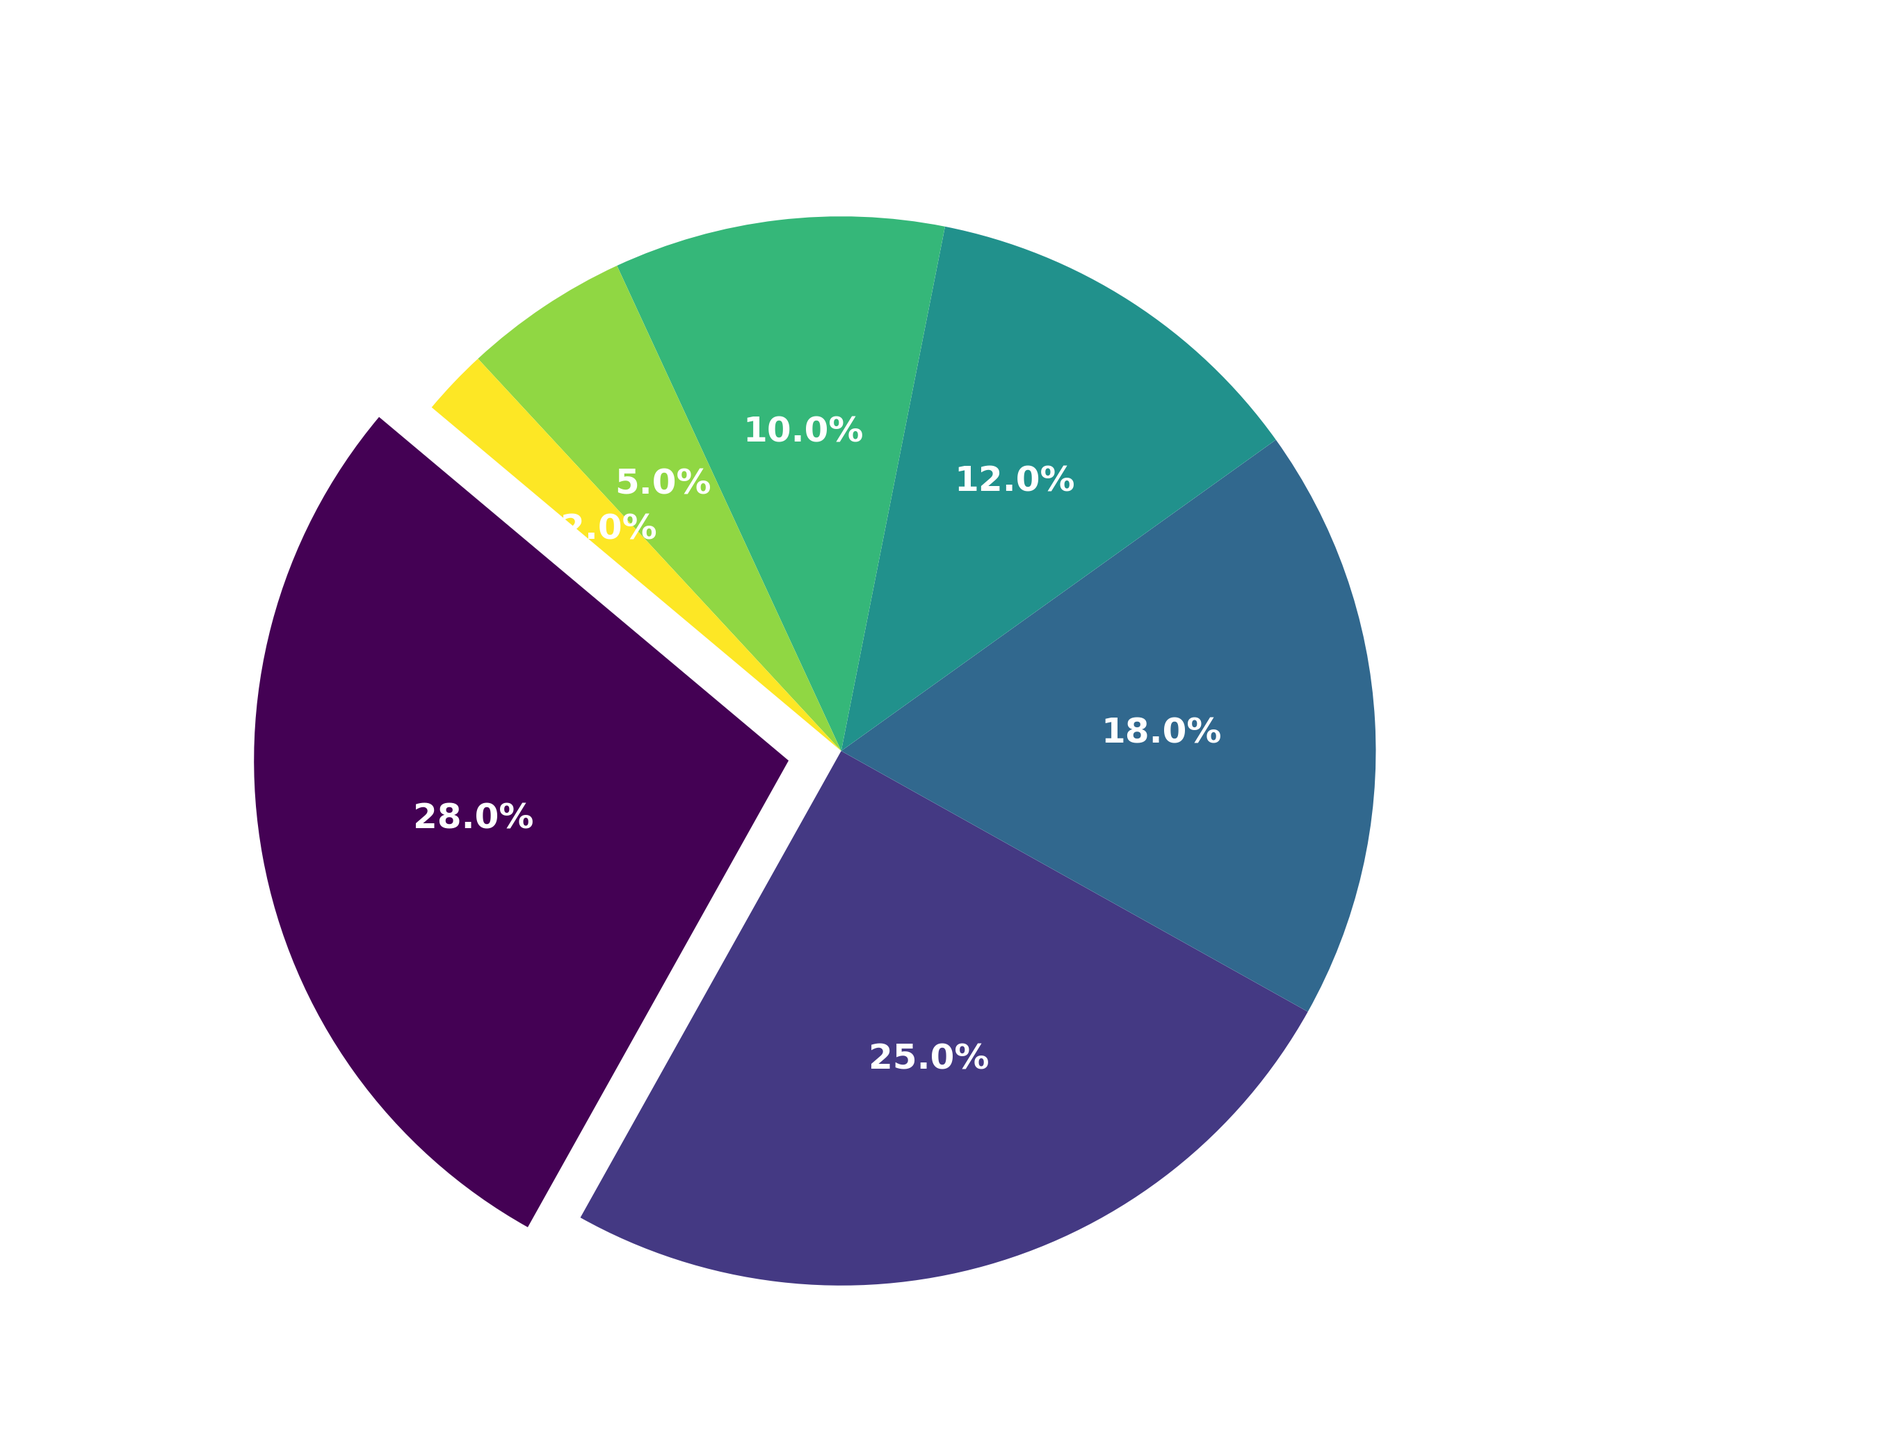What percentage of fans support the top two teams combined? First, identify the percentages for the top two teams. APOEL FC has 28% and Omonia Nicosia has 25%. Add them together: 28 + 25 = 53. So, 53% of fans support the top two teams.
Answer: 53% Which team has the smallest fanbase, and what percentage does it represent? By looking at the percentages, AEK Larnaca has 5%, and 'Other' has 2%. Since 2% < 5%, 'Other' represents the smallest fanbase.
Answer: Other, 2% What is the difference in fan percentages between AEL Limassol and Apollon Limassol? Identify the percentages: AEL Limassol has 12% and Apollon Limassol has 10%. The difference is calculated as 12% - 10% = 2%.
Answer: 2% How much more popular is APOEL FC compared to Anorthosis Famagusta in terms of fan percentage? APOEL FC has 28% and Anorthosis Famagusta has 18%. The difference is calculated as 28% - 18% = 10%. Therefore, APOEL FC is 10% more popular.
Answer: 10% What percentage of fans do not support any of the top five teams? Sum the percentages for the top five teams: 28% (APOEL FC) + 25% (Omonia Nicosia) + 18% (Anorthosis Famagusta) + 12% (AEL Limassol) + 10% (Apollon Limassol) = 93%. Since the total must equal 100%, the percentage of fans not supporting the top five is 100% - 93% = 7%.
Answer: 7% Rank the teams from most popular to least popular based on fan percentage. To rank, simply order the teams by their percentages from highest to lowest: 1. APOEL FC (28%), 2. Omonia Nicosia (25%), 3. Anorthosis Famagusta (18%), 4. AEL Limassol (12%), 5. Apollon Limassol (10%), 6. AEK Larnaca (5%), 7. Other (2%).
Answer: APOEL FC, Omonia Nicosia, Anorthosis Famagusta, AEL Limassol, Apollon Limassol, AEK Larnaca, Other How many times larger is the fanbase for APOEL FC compared to AEK Larnaca? APOEL FC has 28%, and AEK Larnaca has 5%. To find how many times larger APOEL's fanbase is, divide 28 by 5, which equals 5.6 times.
Answer: 5.6 times What is the average percentage of fans for AEK Larnaca, Apollon Limassol, and AEL Limassol? Identify their percentages: AEK Larnaca (5%), Apollon Limassol (10%), AEL Limassol (12%). Calculate the sum: 5 + 10 + 12 = 27. Divide by the number of teams: 27 / 3 = 9.
Answer: 9% Which team is highlighted or exploded in the pie chart? The visual description notes that the first slice, APOEL FC, is exploded for emphasis.
Answer: APOEL FC 